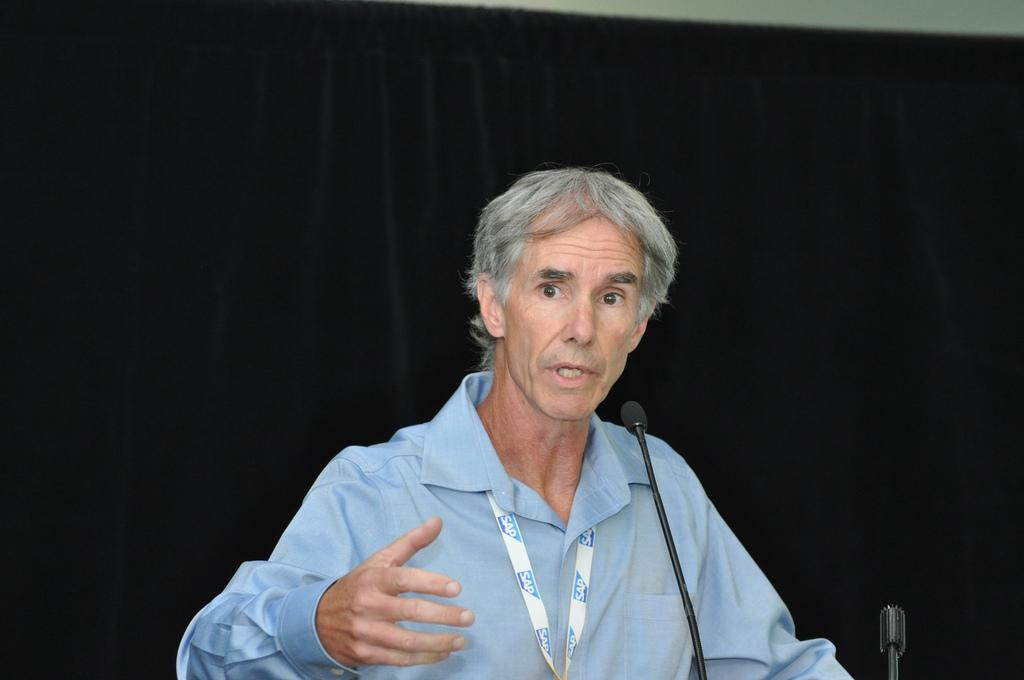Who or what is the main subject in the image? There is a person in the image. What object is in front of the person? There is a mic in front of the person. How many toes can be seen on the person's foot in the image? There is no visible foot or toes in the image, so it cannot be determined. 